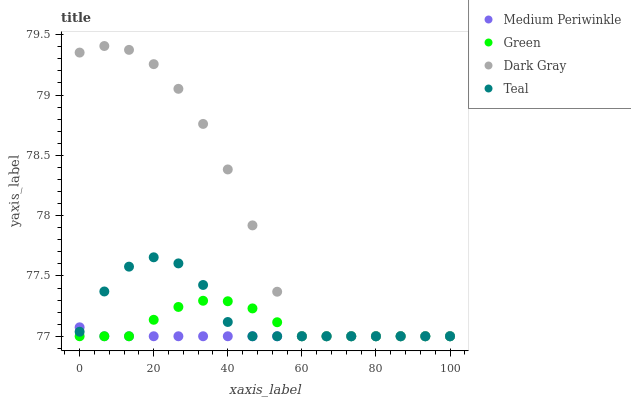Does Medium Periwinkle have the minimum area under the curve?
Answer yes or no. Yes. Does Dark Gray have the maximum area under the curve?
Answer yes or no. Yes. Does Green have the minimum area under the curve?
Answer yes or no. No. Does Green have the maximum area under the curve?
Answer yes or no. No. Is Medium Periwinkle the smoothest?
Answer yes or no. Yes. Is Dark Gray the roughest?
Answer yes or no. Yes. Is Green the smoothest?
Answer yes or no. No. Is Green the roughest?
Answer yes or no. No. Does Dark Gray have the lowest value?
Answer yes or no. Yes. Does Dark Gray have the highest value?
Answer yes or no. Yes. Does Green have the highest value?
Answer yes or no. No. Does Green intersect Dark Gray?
Answer yes or no. Yes. Is Green less than Dark Gray?
Answer yes or no. No. Is Green greater than Dark Gray?
Answer yes or no. No. 